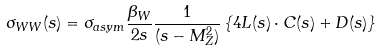<formula> <loc_0><loc_0><loc_500><loc_500>\sigma _ { W W } ( s ) = \sigma _ { a s y m } \frac { \beta _ { W } } { 2 s } \frac { 1 } { ( s - M _ { Z } ^ { 2 } ) } \left \{ 4 L ( s ) \cdot C ( s ) + D ( s ) \right \}</formula> 